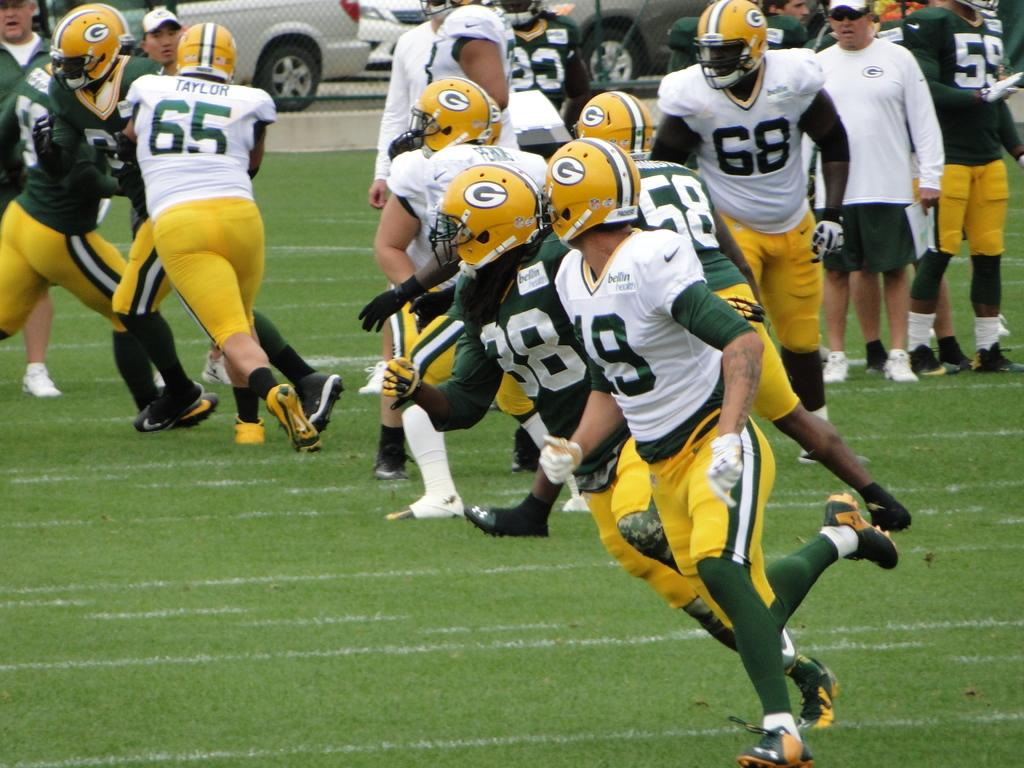What are the people in the image doing? The people in the image are playing. What type of surface can be seen beneath the people? There is grass in the image. What is the boundary that separates the area in the image? There is a fence in the image. What can be seen in the distance in the image? Cars are visible in the background of the image. What type of ink is being used by the people in the image? There is no ink present in the image; the people are playing, not using ink. 